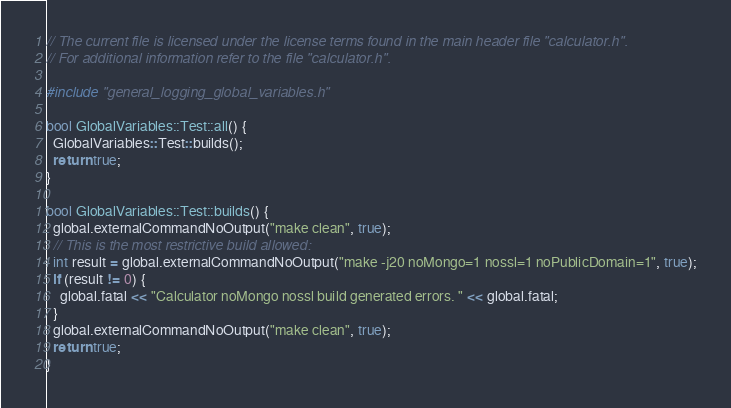<code> <loc_0><loc_0><loc_500><loc_500><_C++_>// The current file is licensed under the license terms found in the main header file "calculator.h".
// For additional information refer to the file "calculator.h".

#include "general_logging_global_variables.h"

bool GlobalVariables::Test::all() {
  GlobalVariables::Test::builds();
  return true;
}

bool GlobalVariables::Test::builds() {
  global.externalCommandNoOutput("make clean", true);
  // This is the most restrictive build allowed:
  int result = global.externalCommandNoOutput("make -j20 noMongo=1 nossl=1 noPublicDomain=1", true);
  if (result != 0) {
    global.fatal << "Calculator noMongo nossl build generated errors. " << global.fatal;
  }
  global.externalCommandNoOutput("make clean", true);
  return true;
}
</code> 